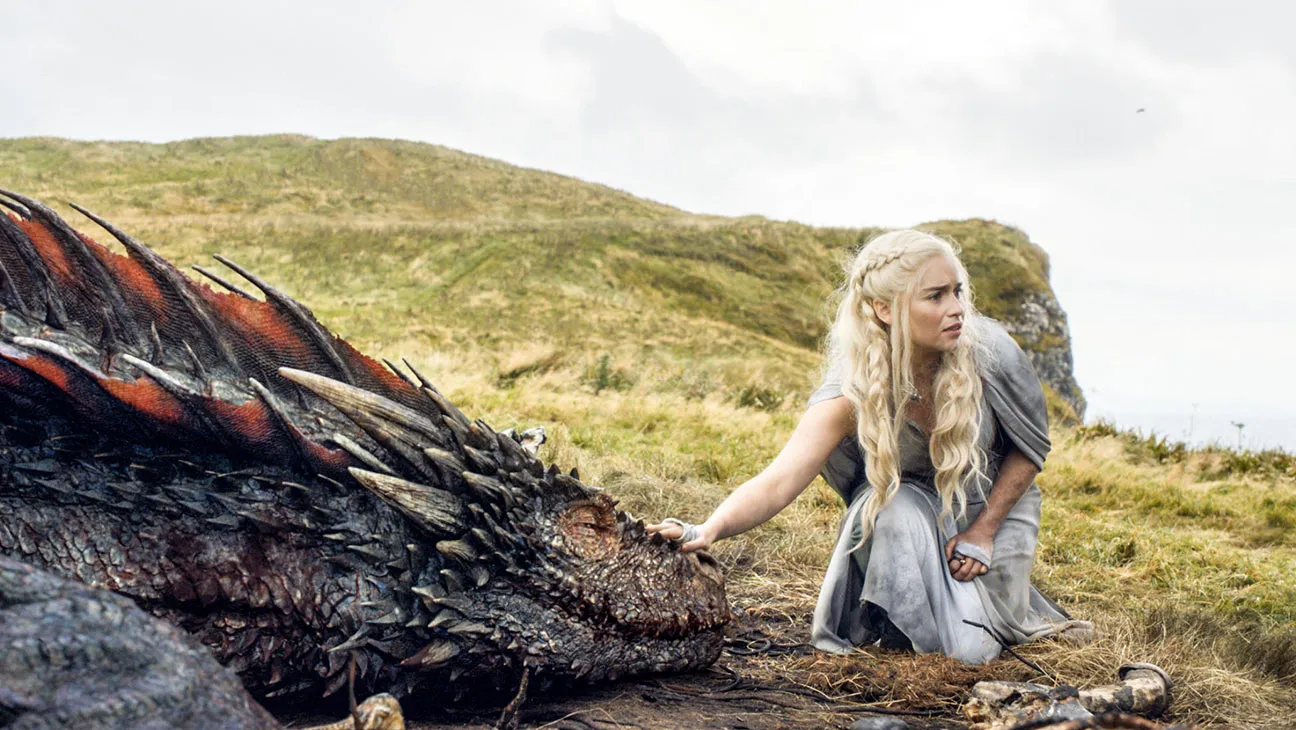What does the setting tell us about this scene? The setting, with rolling hills and a cloudy sky, creates a wild, natural backdrop that enhances the mythical theme. The isolation of the hilltop suggests a private moment away from the chaos of the surrounding world, focusing on the interaction between human and dragon. This environment serves both as a picturesque and a symbolic landscape emphasizing themes of adventure and the crossing of natural boundaries between species. 